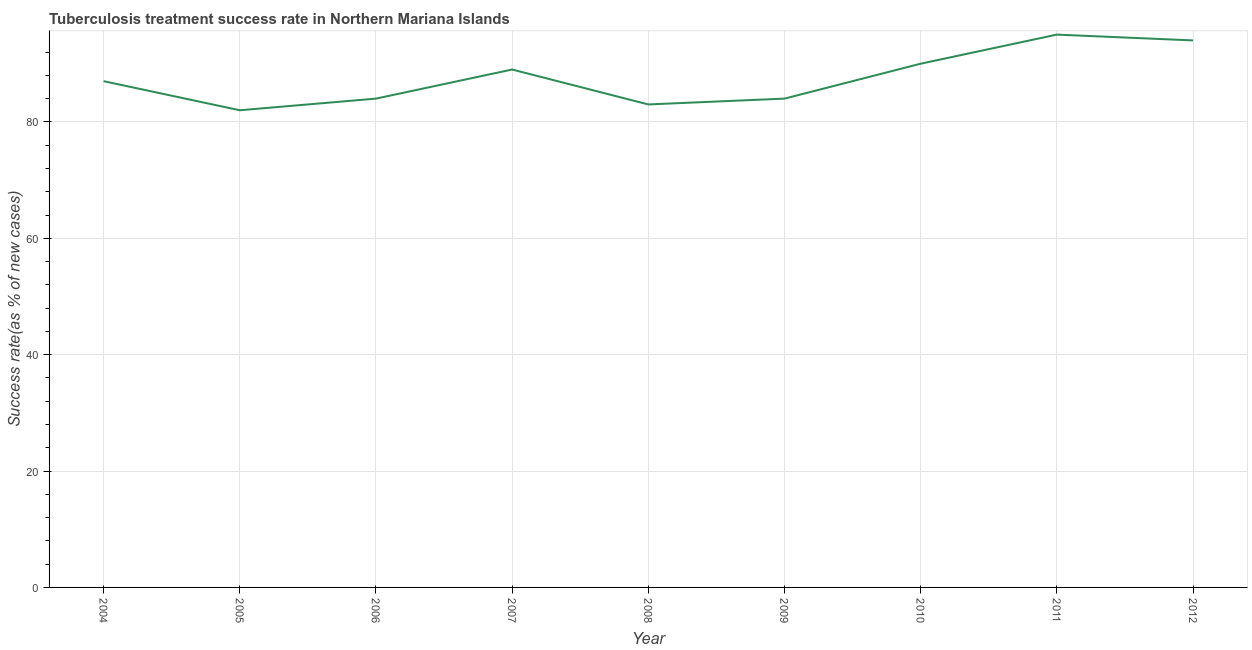What is the tuberculosis treatment success rate in 2008?
Provide a short and direct response. 83. Across all years, what is the maximum tuberculosis treatment success rate?
Keep it short and to the point. 95. Across all years, what is the minimum tuberculosis treatment success rate?
Provide a short and direct response. 82. In which year was the tuberculosis treatment success rate maximum?
Keep it short and to the point. 2011. In which year was the tuberculosis treatment success rate minimum?
Keep it short and to the point. 2005. What is the sum of the tuberculosis treatment success rate?
Provide a succinct answer. 788. What is the difference between the tuberculosis treatment success rate in 2004 and 2007?
Give a very brief answer. -2. What is the average tuberculosis treatment success rate per year?
Your response must be concise. 87.56. In how many years, is the tuberculosis treatment success rate greater than 84 %?
Provide a succinct answer. 5. Do a majority of the years between 2010 and 2007 (inclusive) have tuberculosis treatment success rate greater than 44 %?
Provide a succinct answer. Yes. What is the ratio of the tuberculosis treatment success rate in 2008 to that in 2012?
Provide a short and direct response. 0.88. Is the difference between the tuberculosis treatment success rate in 2005 and 2007 greater than the difference between any two years?
Your answer should be compact. No. What is the difference between the highest and the second highest tuberculosis treatment success rate?
Give a very brief answer. 1. What is the difference between the highest and the lowest tuberculosis treatment success rate?
Keep it short and to the point. 13. Does the tuberculosis treatment success rate monotonically increase over the years?
Keep it short and to the point. No. How many lines are there?
Offer a very short reply. 1. How many years are there in the graph?
Your response must be concise. 9. Does the graph contain any zero values?
Offer a terse response. No. Does the graph contain grids?
Ensure brevity in your answer.  Yes. What is the title of the graph?
Provide a succinct answer. Tuberculosis treatment success rate in Northern Mariana Islands. What is the label or title of the X-axis?
Your answer should be compact. Year. What is the label or title of the Y-axis?
Ensure brevity in your answer.  Success rate(as % of new cases). What is the Success rate(as % of new cases) of 2004?
Your answer should be very brief. 87. What is the Success rate(as % of new cases) in 2005?
Keep it short and to the point. 82. What is the Success rate(as % of new cases) of 2007?
Offer a terse response. 89. What is the Success rate(as % of new cases) of 2008?
Offer a terse response. 83. What is the Success rate(as % of new cases) of 2009?
Your response must be concise. 84. What is the Success rate(as % of new cases) in 2010?
Offer a terse response. 90. What is the Success rate(as % of new cases) in 2012?
Your answer should be compact. 94. What is the difference between the Success rate(as % of new cases) in 2004 and 2007?
Make the answer very short. -2. What is the difference between the Success rate(as % of new cases) in 2004 and 2010?
Keep it short and to the point. -3. What is the difference between the Success rate(as % of new cases) in 2004 and 2011?
Provide a succinct answer. -8. What is the difference between the Success rate(as % of new cases) in 2005 and 2007?
Ensure brevity in your answer.  -7. What is the difference between the Success rate(as % of new cases) in 2005 and 2008?
Give a very brief answer. -1. What is the difference between the Success rate(as % of new cases) in 2005 and 2009?
Make the answer very short. -2. What is the difference between the Success rate(as % of new cases) in 2005 and 2010?
Keep it short and to the point. -8. What is the difference between the Success rate(as % of new cases) in 2005 and 2011?
Ensure brevity in your answer.  -13. What is the difference between the Success rate(as % of new cases) in 2005 and 2012?
Provide a succinct answer. -12. What is the difference between the Success rate(as % of new cases) in 2006 and 2007?
Offer a terse response. -5. What is the difference between the Success rate(as % of new cases) in 2006 and 2008?
Offer a terse response. 1. What is the difference between the Success rate(as % of new cases) in 2006 and 2009?
Make the answer very short. 0. What is the difference between the Success rate(as % of new cases) in 2006 and 2010?
Offer a terse response. -6. What is the difference between the Success rate(as % of new cases) in 2006 and 2012?
Offer a terse response. -10. What is the difference between the Success rate(as % of new cases) in 2007 and 2008?
Give a very brief answer. 6. What is the difference between the Success rate(as % of new cases) in 2007 and 2009?
Your answer should be compact. 5. What is the difference between the Success rate(as % of new cases) in 2007 and 2010?
Make the answer very short. -1. What is the difference between the Success rate(as % of new cases) in 2007 and 2011?
Your answer should be very brief. -6. What is the difference between the Success rate(as % of new cases) in 2009 and 2010?
Offer a terse response. -6. What is the difference between the Success rate(as % of new cases) in 2009 and 2011?
Your answer should be compact. -11. What is the difference between the Success rate(as % of new cases) in 2009 and 2012?
Offer a very short reply. -10. What is the ratio of the Success rate(as % of new cases) in 2004 to that in 2005?
Keep it short and to the point. 1.06. What is the ratio of the Success rate(as % of new cases) in 2004 to that in 2006?
Your answer should be very brief. 1.04. What is the ratio of the Success rate(as % of new cases) in 2004 to that in 2007?
Ensure brevity in your answer.  0.98. What is the ratio of the Success rate(as % of new cases) in 2004 to that in 2008?
Your response must be concise. 1.05. What is the ratio of the Success rate(as % of new cases) in 2004 to that in 2009?
Offer a very short reply. 1.04. What is the ratio of the Success rate(as % of new cases) in 2004 to that in 2010?
Give a very brief answer. 0.97. What is the ratio of the Success rate(as % of new cases) in 2004 to that in 2011?
Provide a short and direct response. 0.92. What is the ratio of the Success rate(as % of new cases) in 2004 to that in 2012?
Offer a terse response. 0.93. What is the ratio of the Success rate(as % of new cases) in 2005 to that in 2007?
Ensure brevity in your answer.  0.92. What is the ratio of the Success rate(as % of new cases) in 2005 to that in 2008?
Offer a terse response. 0.99. What is the ratio of the Success rate(as % of new cases) in 2005 to that in 2010?
Your answer should be compact. 0.91. What is the ratio of the Success rate(as % of new cases) in 2005 to that in 2011?
Your answer should be compact. 0.86. What is the ratio of the Success rate(as % of new cases) in 2005 to that in 2012?
Make the answer very short. 0.87. What is the ratio of the Success rate(as % of new cases) in 2006 to that in 2007?
Provide a succinct answer. 0.94. What is the ratio of the Success rate(as % of new cases) in 2006 to that in 2009?
Offer a very short reply. 1. What is the ratio of the Success rate(as % of new cases) in 2006 to that in 2010?
Your answer should be very brief. 0.93. What is the ratio of the Success rate(as % of new cases) in 2006 to that in 2011?
Your response must be concise. 0.88. What is the ratio of the Success rate(as % of new cases) in 2006 to that in 2012?
Provide a succinct answer. 0.89. What is the ratio of the Success rate(as % of new cases) in 2007 to that in 2008?
Your answer should be very brief. 1.07. What is the ratio of the Success rate(as % of new cases) in 2007 to that in 2009?
Give a very brief answer. 1.06. What is the ratio of the Success rate(as % of new cases) in 2007 to that in 2011?
Provide a succinct answer. 0.94. What is the ratio of the Success rate(as % of new cases) in 2007 to that in 2012?
Ensure brevity in your answer.  0.95. What is the ratio of the Success rate(as % of new cases) in 2008 to that in 2009?
Ensure brevity in your answer.  0.99. What is the ratio of the Success rate(as % of new cases) in 2008 to that in 2010?
Provide a succinct answer. 0.92. What is the ratio of the Success rate(as % of new cases) in 2008 to that in 2011?
Make the answer very short. 0.87. What is the ratio of the Success rate(as % of new cases) in 2008 to that in 2012?
Your answer should be compact. 0.88. What is the ratio of the Success rate(as % of new cases) in 2009 to that in 2010?
Your response must be concise. 0.93. What is the ratio of the Success rate(as % of new cases) in 2009 to that in 2011?
Provide a short and direct response. 0.88. What is the ratio of the Success rate(as % of new cases) in 2009 to that in 2012?
Ensure brevity in your answer.  0.89. What is the ratio of the Success rate(as % of new cases) in 2010 to that in 2011?
Your answer should be very brief. 0.95. 